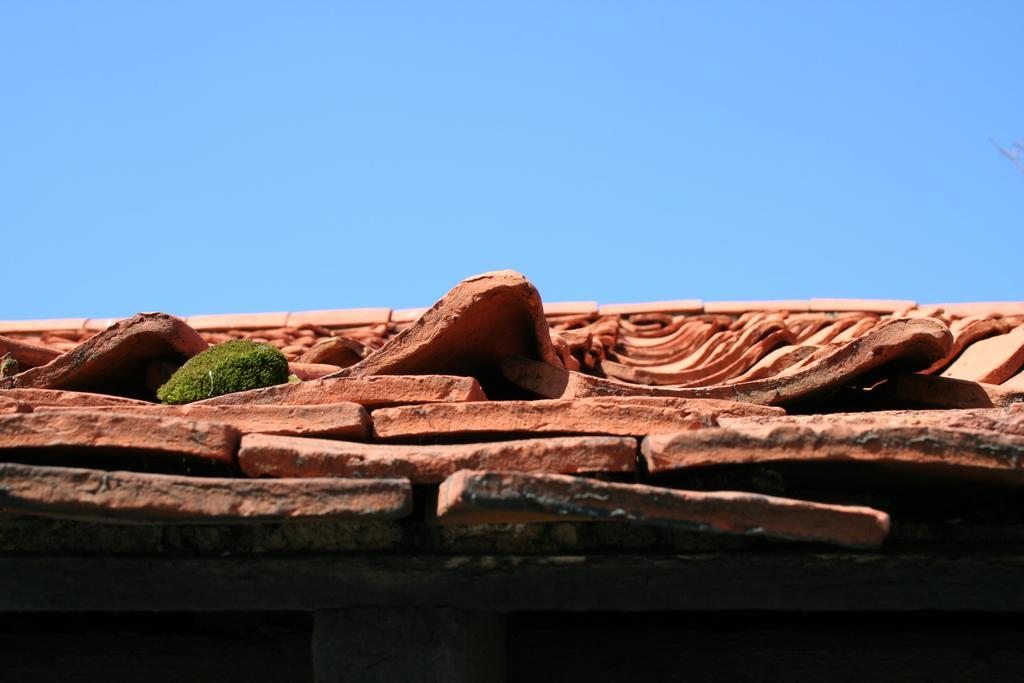Please provide a concise description of this image. In this image, we can see a roof and on the roof, there are bricks. 